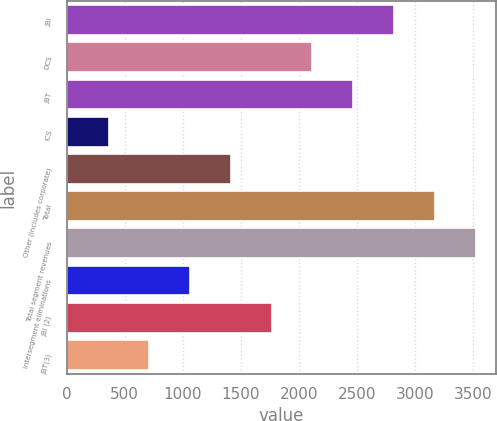Convert chart. <chart><loc_0><loc_0><loc_500><loc_500><bar_chart><fcel>JBI<fcel>DCS<fcel>JBT<fcel>ICS<fcel>Other (includes corporate)<fcel>Total<fcel>Total segment revenues<fcel>Intersegment eliminations<fcel>JBI (2)<fcel>JBT(3)<nl><fcel>2821.4<fcel>2118.8<fcel>2470.1<fcel>362.3<fcel>1416.2<fcel>3172.7<fcel>3524<fcel>1064.9<fcel>1767.5<fcel>713.6<nl></chart> 